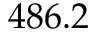Convert formula to latex. <formula><loc_0><loc_0><loc_500><loc_500>4 8 6 . 2</formula> 